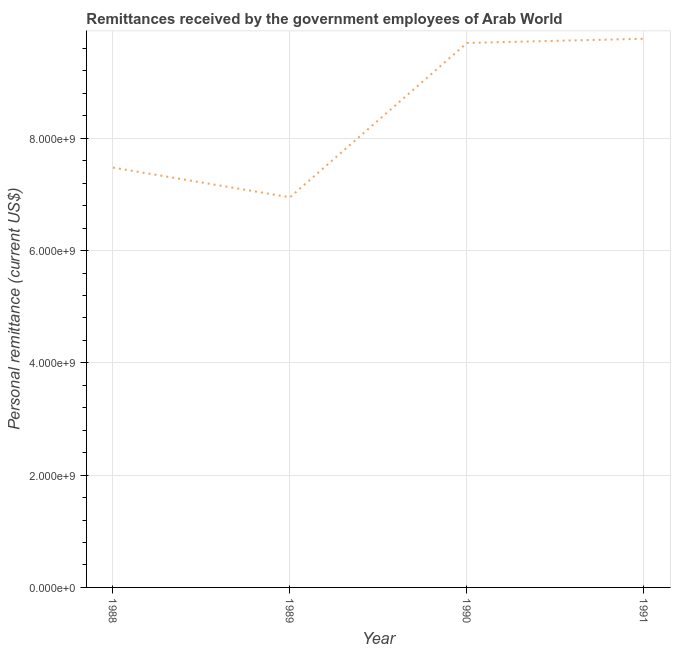What is the personal remittances in 1988?
Make the answer very short. 7.48e+09. Across all years, what is the maximum personal remittances?
Provide a short and direct response. 9.77e+09. Across all years, what is the minimum personal remittances?
Ensure brevity in your answer.  6.95e+09. In which year was the personal remittances maximum?
Offer a terse response. 1991. What is the sum of the personal remittances?
Give a very brief answer. 3.39e+1. What is the difference between the personal remittances in 1988 and 1990?
Your answer should be compact. -2.22e+09. What is the average personal remittances per year?
Make the answer very short. 8.48e+09. What is the median personal remittances?
Your answer should be very brief. 8.59e+09. In how many years, is the personal remittances greater than 7600000000 US$?
Your response must be concise. 2. What is the ratio of the personal remittances in 1988 to that in 1991?
Provide a succinct answer. 0.77. Is the personal remittances in 1988 less than that in 1990?
Your answer should be compact. Yes. Is the difference between the personal remittances in 1989 and 1990 greater than the difference between any two years?
Offer a terse response. No. What is the difference between the highest and the second highest personal remittances?
Offer a very short reply. 7.45e+07. Is the sum of the personal remittances in 1988 and 1991 greater than the maximum personal remittances across all years?
Ensure brevity in your answer.  Yes. What is the difference between the highest and the lowest personal remittances?
Give a very brief answer. 2.82e+09. In how many years, is the personal remittances greater than the average personal remittances taken over all years?
Your answer should be very brief. 2. How many lines are there?
Your answer should be very brief. 1. How many years are there in the graph?
Your answer should be very brief. 4. What is the difference between two consecutive major ticks on the Y-axis?
Keep it short and to the point. 2.00e+09. Does the graph contain any zero values?
Keep it short and to the point. No. What is the title of the graph?
Your response must be concise. Remittances received by the government employees of Arab World. What is the label or title of the X-axis?
Provide a short and direct response. Year. What is the label or title of the Y-axis?
Provide a succinct answer. Personal remittance (current US$). What is the Personal remittance (current US$) in 1988?
Offer a terse response. 7.48e+09. What is the Personal remittance (current US$) in 1989?
Your response must be concise. 6.95e+09. What is the Personal remittance (current US$) of 1990?
Provide a short and direct response. 9.70e+09. What is the Personal remittance (current US$) of 1991?
Provide a short and direct response. 9.77e+09. What is the difference between the Personal remittance (current US$) in 1988 and 1989?
Your answer should be compact. 5.29e+08. What is the difference between the Personal remittance (current US$) in 1988 and 1990?
Make the answer very short. -2.22e+09. What is the difference between the Personal remittance (current US$) in 1988 and 1991?
Make the answer very short. -2.30e+09. What is the difference between the Personal remittance (current US$) in 1989 and 1990?
Provide a short and direct response. -2.75e+09. What is the difference between the Personal remittance (current US$) in 1989 and 1991?
Your answer should be compact. -2.82e+09. What is the difference between the Personal remittance (current US$) in 1990 and 1991?
Your answer should be very brief. -7.45e+07. What is the ratio of the Personal remittance (current US$) in 1988 to that in 1989?
Offer a terse response. 1.08. What is the ratio of the Personal remittance (current US$) in 1988 to that in 1990?
Your answer should be very brief. 0.77. What is the ratio of the Personal remittance (current US$) in 1988 to that in 1991?
Make the answer very short. 0.77. What is the ratio of the Personal remittance (current US$) in 1989 to that in 1990?
Give a very brief answer. 0.72. What is the ratio of the Personal remittance (current US$) in 1989 to that in 1991?
Keep it short and to the point. 0.71. What is the ratio of the Personal remittance (current US$) in 1990 to that in 1991?
Provide a short and direct response. 0.99. 